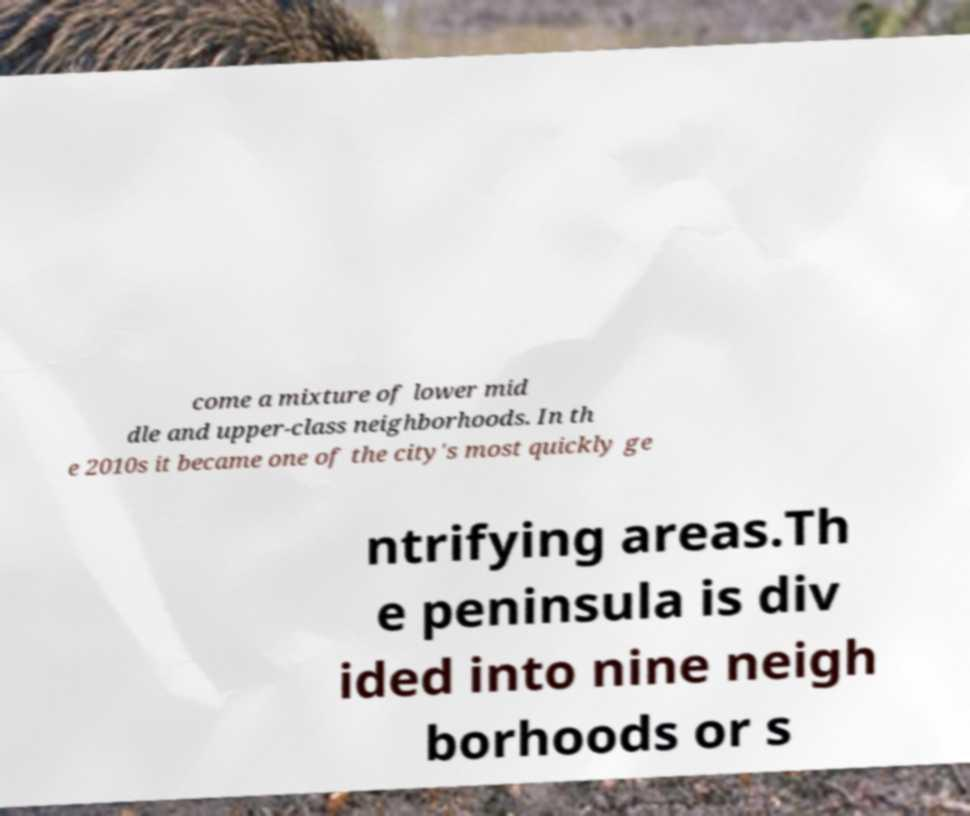Can you accurately transcribe the text from the provided image for me? come a mixture of lower mid dle and upper-class neighborhoods. In th e 2010s it became one of the city's most quickly ge ntrifying areas.Th e peninsula is div ided into nine neigh borhoods or s 